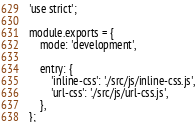Convert code to text. <code><loc_0><loc_0><loc_500><loc_500><_JavaScript_>'use strict';

module.exports = {
	mode: 'development',

	entry: {
		'inline-css': './src/js/inline-css.js',
		'url-css': './src/js/url-css.js',
	},
};
</code> 